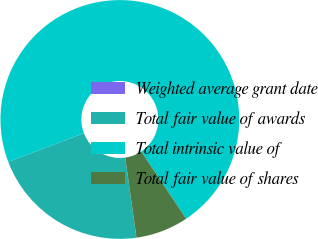<chart> <loc_0><loc_0><loc_500><loc_500><pie_chart><fcel>Weighted average grant date<fcel>Total fair value of awards<fcel>Total intrinsic value of<fcel>Total fair value of shares<nl><fcel>0.01%<fcel>21.43%<fcel>71.42%<fcel>7.15%<nl></chart> 